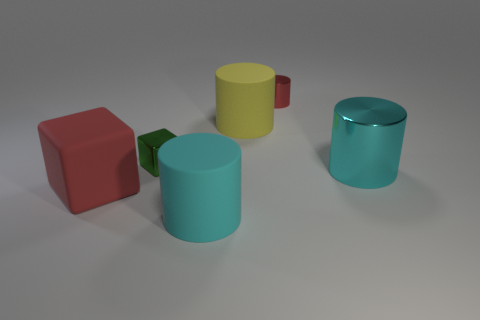Subtract all red cylinders. Subtract all cyan blocks. How many cylinders are left? 3 Add 3 green cylinders. How many objects exist? 9 Subtract all blocks. How many objects are left? 4 Add 2 tiny red metallic things. How many tiny red metallic things exist? 3 Subtract 0 blue spheres. How many objects are left? 6 Subtract all big purple shiny spheres. Subtract all small shiny things. How many objects are left? 4 Add 5 big rubber cubes. How many big rubber cubes are left? 6 